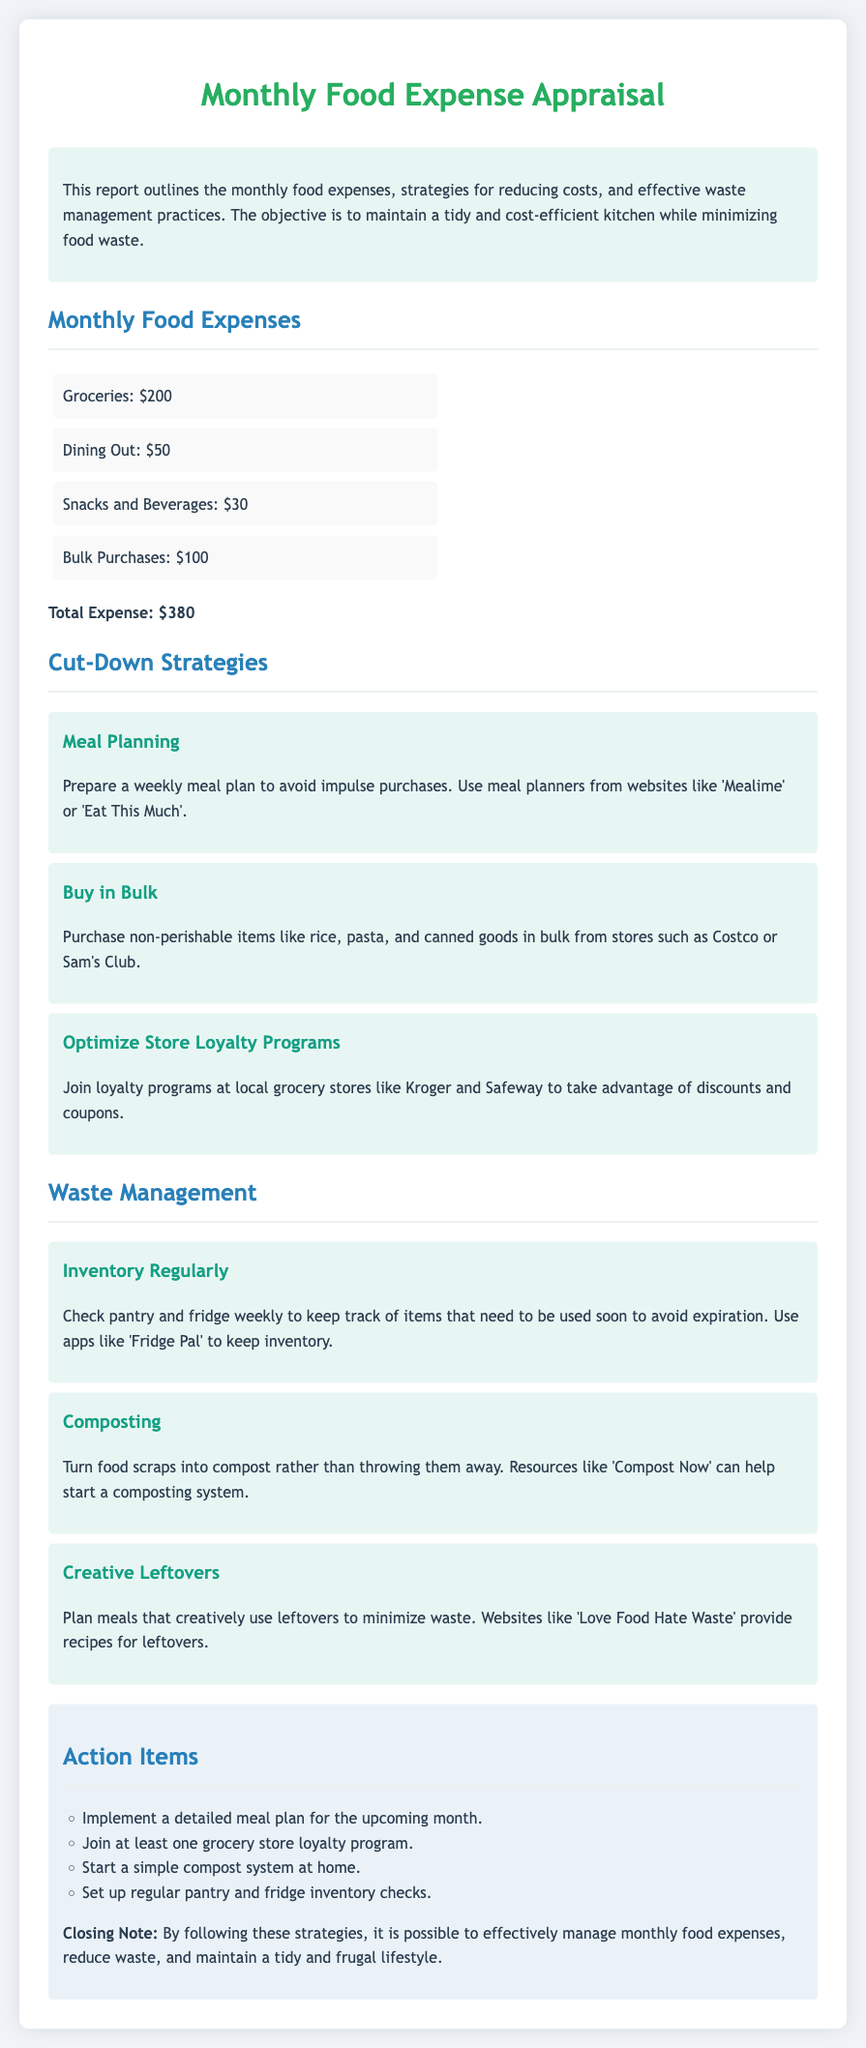What is the total expense? The total expense is located in the summary of the expenses section, calculated from the listed items.
Answer: $380 What is one strategy for cut-down on expenses? The document lists several strategies, one of which is provided under the cut-down strategies section.
Answer: Meal Planning Which item has the highest expense in the report? The highest expense item can be found in the monthly food expenses breakdown.
Answer: Groceries How many action items are listed in the conclusion? The conclusion section provides a specific list of actions to take, counted for the answer.
Answer: 4 What resource can help start a compost system? The waste management section mentions a specific resource that can assist in composting.
Answer: Compost Now What is a suggested app for inventory management? An app for inventory management is recommended in the waste management strategies.
Answer: Fridge Pal Which grocery store loyalty program is mentioned? The reasoning behind optimizing loyalty programs is explained with an example store.
Answer: Kroger What type of meals should be planned to minimize waste? The document suggests planning meals that utilize leftovers as part of waste management.
Answer: Creative Leftovers 